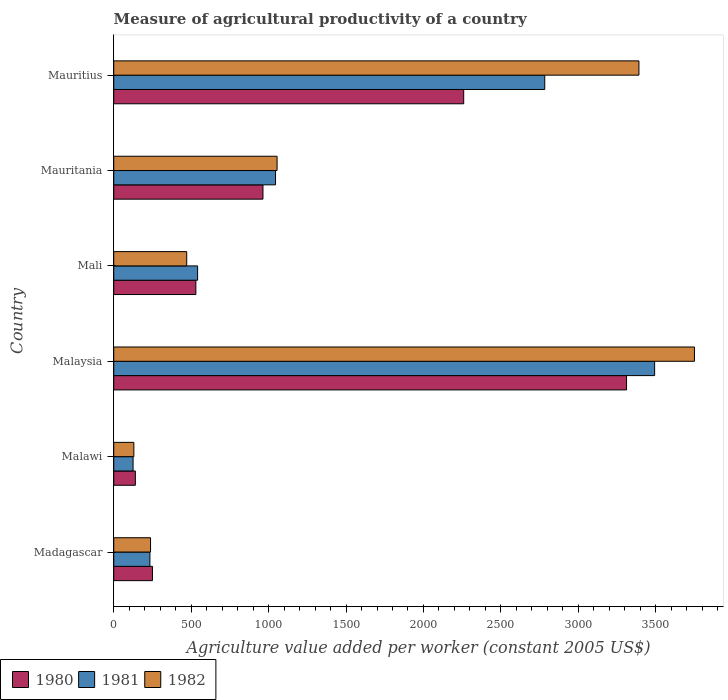Are the number of bars per tick equal to the number of legend labels?
Your answer should be compact. Yes. How many bars are there on the 6th tick from the top?
Make the answer very short. 3. How many bars are there on the 2nd tick from the bottom?
Your answer should be compact. 3. What is the label of the 6th group of bars from the top?
Give a very brief answer. Madagascar. In how many cases, is the number of bars for a given country not equal to the number of legend labels?
Ensure brevity in your answer.  0. What is the measure of agricultural productivity in 1982 in Mauritania?
Make the answer very short. 1054.73. Across all countries, what is the maximum measure of agricultural productivity in 1980?
Your answer should be compact. 3311.27. Across all countries, what is the minimum measure of agricultural productivity in 1980?
Provide a succinct answer. 139.62. In which country was the measure of agricultural productivity in 1980 maximum?
Your answer should be compact. Malaysia. In which country was the measure of agricultural productivity in 1980 minimum?
Offer a very short reply. Malawi. What is the total measure of agricultural productivity in 1982 in the graph?
Provide a succinct answer. 9034.51. What is the difference between the measure of agricultural productivity in 1981 in Mali and that in Mauritius?
Ensure brevity in your answer.  -2241.48. What is the difference between the measure of agricultural productivity in 1982 in Mauritius and the measure of agricultural productivity in 1980 in Madagascar?
Offer a very short reply. 3141.07. What is the average measure of agricultural productivity in 1982 per country?
Your answer should be very brief. 1505.75. What is the difference between the measure of agricultural productivity in 1980 and measure of agricultural productivity in 1981 in Mali?
Your response must be concise. -11.31. In how many countries, is the measure of agricultural productivity in 1981 greater than 1400 US$?
Give a very brief answer. 2. What is the ratio of the measure of agricultural productivity in 1980 in Malawi to that in Mauritania?
Provide a succinct answer. 0.14. What is the difference between the highest and the second highest measure of agricultural productivity in 1981?
Give a very brief answer. 709.52. What is the difference between the highest and the lowest measure of agricultural productivity in 1982?
Your response must be concise. 3619.9. In how many countries, is the measure of agricultural productivity in 1981 greater than the average measure of agricultural productivity in 1981 taken over all countries?
Your answer should be compact. 2. Is it the case that in every country, the sum of the measure of agricultural productivity in 1981 and measure of agricultural productivity in 1980 is greater than the measure of agricultural productivity in 1982?
Keep it short and to the point. Yes. How many countries are there in the graph?
Offer a very short reply. 6. What is the difference between two consecutive major ticks on the X-axis?
Offer a very short reply. 500. Does the graph contain any zero values?
Your answer should be compact. No. How many legend labels are there?
Offer a terse response. 3. What is the title of the graph?
Your answer should be compact. Measure of agricultural productivity of a country. What is the label or title of the X-axis?
Ensure brevity in your answer.  Agriculture value added per worker (constant 2005 US$). What is the label or title of the Y-axis?
Your answer should be compact. Country. What is the Agriculture value added per worker (constant 2005 US$) of 1980 in Madagascar?
Offer a very short reply. 250.1. What is the Agriculture value added per worker (constant 2005 US$) in 1981 in Madagascar?
Provide a succinct answer. 233.51. What is the Agriculture value added per worker (constant 2005 US$) in 1982 in Madagascar?
Offer a terse response. 237.65. What is the Agriculture value added per worker (constant 2005 US$) in 1980 in Malawi?
Give a very brief answer. 139.62. What is the Agriculture value added per worker (constant 2005 US$) of 1981 in Malawi?
Make the answer very short. 124.86. What is the Agriculture value added per worker (constant 2005 US$) of 1982 in Malawi?
Your response must be concise. 129.9. What is the Agriculture value added per worker (constant 2005 US$) in 1980 in Malaysia?
Keep it short and to the point. 3311.27. What is the Agriculture value added per worker (constant 2005 US$) in 1981 in Malaysia?
Your answer should be compact. 3492.6. What is the Agriculture value added per worker (constant 2005 US$) of 1982 in Malaysia?
Your answer should be very brief. 3749.8. What is the Agriculture value added per worker (constant 2005 US$) in 1980 in Mali?
Provide a short and direct response. 530.29. What is the Agriculture value added per worker (constant 2005 US$) of 1981 in Mali?
Provide a short and direct response. 541.6. What is the Agriculture value added per worker (constant 2005 US$) of 1982 in Mali?
Your response must be concise. 471.28. What is the Agriculture value added per worker (constant 2005 US$) of 1980 in Mauritania?
Provide a short and direct response. 963.64. What is the Agriculture value added per worker (constant 2005 US$) of 1981 in Mauritania?
Offer a terse response. 1044.71. What is the Agriculture value added per worker (constant 2005 US$) of 1982 in Mauritania?
Make the answer very short. 1054.73. What is the Agriculture value added per worker (constant 2005 US$) of 1980 in Mauritius?
Make the answer very short. 2259.73. What is the Agriculture value added per worker (constant 2005 US$) of 1981 in Mauritius?
Make the answer very short. 2783.08. What is the Agriculture value added per worker (constant 2005 US$) of 1982 in Mauritius?
Make the answer very short. 3391.17. Across all countries, what is the maximum Agriculture value added per worker (constant 2005 US$) in 1980?
Your answer should be very brief. 3311.27. Across all countries, what is the maximum Agriculture value added per worker (constant 2005 US$) in 1981?
Your response must be concise. 3492.6. Across all countries, what is the maximum Agriculture value added per worker (constant 2005 US$) in 1982?
Your answer should be very brief. 3749.8. Across all countries, what is the minimum Agriculture value added per worker (constant 2005 US$) of 1980?
Give a very brief answer. 139.62. Across all countries, what is the minimum Agriculture value added per worker (constant 2005 US$) of 1981?
Make the answer very short. 124.86. Across all countries, what is the minimum Agriculture value added per worker (constant 2005 US$) of 1982?
Make the answer very short. 129.9. What is the total Agriculture value added per worker (constant 2005 US$) in 1980 in the graph?
Your answer should be compact. 7454.65. What is the total Agriculture value added per worker (constant 2005 US$) in 1981 in the graph?
Provide a short and direct response. 8220.37. What is the total Agriculture value added per worker (constant 2005 US$) of 1982 in the graph?
Give a very brief answer. 9034.51. What is the difference between the Agriculture value added per worker (constant 2005 US$) in 1980 in Madagascar and that in Malawi?
Your response must be concise. 110.47. What is the difference between the Agriculture value added per worker (constant 2005 US$) in 1981 in Madagascar and that in Malawi?
Provide a short and direct response. 108.65. What is the difference between the Agriculture value added per worker (constant 2005 US$) in 1982 in Madagascar and that in Malawi?
Your answer should be compact. 107.75. What is the difference between the Agriculture value added per worker (constant 2005 US$) of 1980 in Madagascar and that in Malaysia?
Your response must be concise. -3061.17. What is the difference between the Agriculture value added per worker (constant 2005 US$) of 1981 in Madagascar and that in Malaysia?
Ensure brevity in your answer.  -3259.09. What is the difference between the Agriculture value added per worker (constant 2005 US$) in 1982 in Madagascar and that in Malaysia?
Your response must be concise. -3512.15. What is the difference between the Agriculture value added per worker (constant 2005 US$) in 1980 in Madagascar and that in Mali?
Ensure brevity in your answer.  -280.19. What is the difference between the Agriculture value added per worker (constant 2005 US$) of 1981 in Madagascar and that in Mali?
Provide a succinct answer. -308.09. What is the difference between the Agriculture value added per worker (constant 2005 US$) in 1982 in Madagascar and that in Mali?
Offer a very short reply. -233.63. What is the difference between the Agriculture value added per worker (constant 2005 US$) in 1980 in Madagascar and that in Mauritania?
Give a very brief answer. -713.54. What is the difference between the Agriculture value added per worker (constant 2005 US$) in 1981 in Madagascar and that in Mauritania?
Your answer should be very brief. -811.19. What is the difference between the Agriculture value added per worker (constant 2005 US$) of 1982 in Madagascar and that in Mauritania?
Keep it short and to the point. -817.08. What is the difference between the Agriculture value added per worker (constant 2005 US$) of 1980 in Madagascar and that in Mauritius?
Offer a very short reply. -2009.63. What is the difference between the Agriculture value added per worker (constant 2005 US$) of 1981 in Madagascar and that in Mauritius?
Give a very brief answer. -2549.57. What is the difference between the Agriculture value added per worker (constant 2005 US$) of 1982 in Madagascar and that in Mauritius?
Make the answer very short. -3153.52. What is the difference between the Agriculture value added per worker (constant 2005 US$) in 1980 in Malawi and that in Malaysia?
Give a very brief answer. -3171.65. What is the difference between the Agriculture value added per worker (constant 2005 US$) in 1981 in Malawi and that in Malaysia?
Give a very brief answer. -3367.74. What is the difference between the Agriculture value added per worker (constant 2005 US$) in 1982 in Malawi and that in Malaysia?
Provide a short and direct response. -3619.9. What is the difference between the Agriculture value added per worker (constant 2005 US$) in 1980 in Malawi and that in Mali?
Your answer should be compact. -390.66. What is the difference between the Agriculture value added per worker (constant 2005 US$) of 1981 in Malawi and that in Mali?
Your response must be concise. -416.74. What is the difference between the Agriculture value added per worker (constant 2005 US$) of 1982 in Malawi and that in Mali?
Provide a succinct answer. -341.38. What is the difference between the Agriculture value added per worker (constant 2005 US$) of 1980 in Malawi and that in Mauritania?
Ensure brevity in your answer.  -824.02. What is the difference between the Agriculture value added per worker (constant 2005 US$) in 1981 in Malawi and that in Mauritania?
Your response must be concise. -919.84. What is the difference between the Agriculture value added per worker (constant 2005 US$) of 1982 in Malawi and that in Mauritania?
Your response must be concise. -924.83. What is the difference between the Agriculture value added per worker (constant 2005 US$) in 1980 in Malawi and that in Mauritius?
Provide a short and direct response. -2120.1. What is the difference between the Agriculture value added per worker (constant 2005 US$) in 1981 in Malawi and that in Mauritius?
Offer a very short reply. -2658.22. What is the difference between the Agriculture value added per worker (constant 2005 US$) in 1982 in Malawi and that in Mauritius?
Your answer should be compact. -3261.27. What is the difference between the Agriculture value added per worker (constant 2005 US$) in 1980 in Malaysia and that in Mali?
Give a very brief answer. 2780.98. What is the difference between the Agriculture value added per worker (constant 2005 US$) in 1981 in Malaysia and that in Mali?
Offer a terse response. 2951. What is the difference between the Agriculture value added per worker (constant 2005 US$) in 1982 in Malaysia and that in Mali?
Your response must be concise. 3278.52. What is the difference between the Agriculture value added per worker (constant 2005 US$) of 1980 in Malaysia and that in Mauritania?
Offer a very short reply. 2347.63. What is the difference between the Agriculture value added per worker (constant 2005 US$) in 1981 in Malaysia and that in Mauritania?
Make the answer very short. 2447.9. What is the difference between the Agriculture value added per worker (constant 2005 US$) of 1982 in Malaysia and that in Mauritania?
Give a very brief answer. 2695.07. What is the difference between the Agriculture value added per worker (constant 2005 US$) of 1980 in Malaysia and that in Mauritius?
Your response must be concise. 1051.54. What is the difference between the Agriculture value added per worker (constant 2005 US$) of 1981 in Malaysia and that in Mauritius?
Your answer should be compact. 709.52. What is the difference between the Agriculture value added per worker (constant 2005 US$) of 1982 in Malaysia and that in Mauritius?
Your response must be concise. 358.63. What is the difference between the Agriculture value added per worker (constant 2005 US$) in 1980 in Mali and that in Mauritania?
Your response must be concise. -433.35. What is the difference between the Agriculture value added per worker (constant 2005 US$) in 1981 in Mali and that in Mauritania?
Provide a short and direct response. -503.1. What is the difference between the Agriculture value added per worker (constant 2005 US$) in 1982 in Mali and that in Mauritania?
Offer a very short reply. -583.45. What is the difference between the Agriculture value added per worker (constant 2005 US$) in 1980 in Mali and that in Mauritius?
Provide a succinct answer. -1729.44. What is the difference between the Agriculture value added per worker (constant 2005 US$) of 1981 in Mali and that in Mauritius?
Your answer should be very brief. -2241.48. What is the difference between the Agriculture value added per worker (constant 2005 US$) in 1982 in Mali and that in Mauritius?
Give a very brief answer. -2919.89. What is the difference between the Agriculture value added per worker (constant 2005 US$) in 1980 in Mauritania and that in Mauritius?
Make the answer very short. -1296.09. What is the difference between the Agriculture value added per worker (constant 2005 US$) of 1981 in Mauritania and that in Mauritius?
Give a very brief answer. -1738.38. What is the difference between the Agriculture value added per worker (constant 2005 US$) of 1982 in Mauritania and that in Mauritius?
Offer a very short reply. -2336.44. What is the difference between the Agriculture value added per worker (constant 2005 US$) of 1980 in Madagascar and the Agriculture value added per worker (constant 2005 US$) of 1981 in Malawi?
Make the answer very short. 125.24. What is the difference between the Agriculture value added per worker (constant 2005 US$) of 1980 in Madagascar and the Agriculture value added per worker (constant 2005 US$) of 1982 in Malawi?
Your answer should be very brief. 120.2. What is the difference between the Agriculture value added per worker (constant 2005 US$) of 1981 in Madagascar and the Agriculture value added per worker (constant 2005 US$) of 1982 in Malawi?
Provide a succinct answer. 103.61. What is the difference between the Agriculture value added per worker (constant 2005 US$) in 1980 in Madagascar and the Agriculture value added per worker (constant 2005 US$) in 1981 in Malaysia?
Your answer should be very brief. -3242.5. What is the difference between the Agriculture value added per worker (constant 2005 US$) of 1980 in Madagascar and the Agriculture value added per worker (constant 2005 US$) of 1982 in Malaysia?
Provide a short and direct response. -3499.7. What is the difference between the Agriculture value added per worker (constant 2005 US$) of 1981 in Madagascar and the Agriculture value added per worker (constant 2005 US$) of 1982 in Malaysia?
Give a very brief answer. -3516.29. What is the difference between the Agriculture value added per worker (constant 2005 US$) of 1980 in Madagascar and the Agriculture value added per worker (constant 2005 US$) of 1981 in Mali?
Give a very brief answer. -291.5. What is the difference between the Agriculture value added per worker (constant 2005 US$) in 1980 in Madagascar and the Agriculture value added per worker (constant 2005 US$) in 1982 in Mali?
Offer a terse response. -221.18. What is the difference between the Agriculture value added per worker (constant 2005 US$) in 1981 in Madagascar and the Agriculture value added per worker (constant 2005 US$) in 1982 in Mali?
Make the answer very short. -237.76. What is the difference between the Agriculture value added per worker (constant 2005 US$) of 1980 in Madagascar and the Agriculture value added per worker (constant 2005 US$) of 1981 in Mauritania?
Offer a very short reply. -794.61. What is the difference between the Agriculture value added per worker (constant 2005 US$) in 1980 in Madagascar and the Agriculture value added per worker (constant 2005 US$) in 1982 in Mauritania?
Provide a succinct answer. -804.63. What is the difference between the Agriculture value added per worker (constant 2005 US$) in 1981 in Madagascar and the Agriculture value added per worker (constant 2005 US$) in 1982 in Mauritania?
Provide a succinct answer. -821.21. What is the difference between the Agriculture value added per worker (constant 2005 US$) of 1980 in Madagascar and the Agriculture value added per worker (constant 2005 US$) of 1981 in Mauritius?
Your response must be concise. -2532.98. What is the difference between the Agriculture value added per worker (constant 2005 US$) of 1980 in Madagascar and the Agriculture value added per worker (constant 2005 US$) of 1982 in Mauritius?
Offer a terse response. -3141.07. What is the difference between the Agriculture value added per worker (constant 2005 US$) in 1981 in Madagascar and the Agriculture value added per worker (constant 2005 US$) in 1982 in Mauritius?
Provide a succinct answer. -3157.66. What is the difference between the Agriculture value added per worker (constant 2005 US$) in 1980 in Malawi and the Agriculture value added per worker (constant 2005 US$) in 1981 in Malaysia?
Ensure brevity in your answer.  -3352.98. What is the difference between the Agriculture value added per worker (constant 2005 US$) in 1980 in Malawi and the Agriculture value added per worker (constant 2005 US$) in 1982 in Malaysia?
Keep it short and to the point. -3610.18. What is the difference between the Agriculture value added per worker (constant 2005 US$) in 1981 in Malawi and the Agriculture value added per worker (constant 2005 US$) in 1982 in Malaysia?
Your answer should be very brief. -3624.94. What is the difference between the Agriculture value added per worker (constant 2005 US$) of 1980 in Malawi and the Agriculture value added per worker (constant 2005 US$) of 1981 in Mali?
Give a very brief answer. -401.98. What is the difference between the Agriculture value added per worker (constant 2005 US$) of 1980 in Malawi and the Agriculture value added per worker (constant 2005 US$) of 1982 in Mali?
Your answer should be compact. -331.65. What is the difference between the Agriculture value added per worker (constant 2005 US$) of 1981 in Malawi and the Agriculture value added per worker (constant 2005 US$) of 1982 in Mali?
Offer a terse response. -346.41. What is the difference between the Agriculture value added per worker (constant 2005 US$) of 1980 in Malawi and the Agriculture value added per worker (constant 2005 US$) of 1981 in Mauritania?
Your answer should be compact. -905.08. What is the difference between the Agriculture value added per worker (constant 2005 US$) of 1980 in Malawi and the Agriculture value added per worker (constant 2005 US$) of 1982 in Mauritania?
Ensure brevity in your answer.  -915.1. What is the difference between the Agriculture value added per worker (constant 2005 US$) in 1981 in Malawi and the Agriculture value added per worker (constant 2005 US$) in 1982 in Mauritania?
Provide a succinct answer. -929.86. What is the difference between the Agriculture value added per worker (constant 2005 US$) of 1980 in Malawi and the Agriculture value added per worker (constant 2005 US$) of 1981 in Mauritius?
Your response must be concise. -2643.46. What is the difference between the Agriculture value added per worker (constant 2005 US$) in 1980 in Malawi and the Agriculture value added per worker (constant 2005 US$) in 1982 in Mauritius?
Provide a succinct answer. -3251.54. What is the difference between the Agriculture value added per worker (constant 2005 US$) in 1981 in Malawi and the Agriculture value added per worker (constant 2005 US$) in 1982 in Mauritius?
Make the answer very short. -3266.3. What is the difference between the Agriculture value added per worker (constant 2005 US$) of 1980 in Malaysia and the Agriculture value added per worker (constant 2005 US$) of 1981 in Mali?
Make the answer very short. 2769.67. What is the difference between the Agriculture value added per worker (constant 2005 US$) in 1980 in Malaysia and the Agriculture value added per worker (constant 2005 US$) in 1982 in Mali?
Offer a terse response. 2839.99. What is the difference between the Agriculture value added per worker (constant 2005 US$) of 1981 in Malaysia and the Agriculture value added per worker (constant 2005 US$) of 1982 in Mali?
Give a very brief answer. 3021.32. What is the difference between the Agriculture value added per worker (constant 2005 US$) of 1980 in Malaysia and the Agriculture value added per worker (constant 2005 US$) of 1981 in Mauritania?
Provide a succinct answer. 2266.57. What is the difference between the Agriculture value added per worker (constant 2005 US$) in 1980 in Malaysia and the Agriculture value added per worker (constant 2005 US$) in 1982 in Mauritania?
Ensure brevity in your answer.  2256.54. What is the difference between the Agriculture value added per worker (constant 2005 US$) of 1981 in Malaysia and the Agriculture value added per worker (constant 2005 US$) of 1982 in Mauritania?
Provide a short and direct response. 2437.88. What is the difference between the Agriculture value added per worker (constant 2005 US$) of 1980 in Malaysia and the Agriculture value added per worker (constant 2005 US$) of 1981 in Mauritius?
Your response must be concise. 528.19. What is the difference between the Agriculture value added per worker (constant 2005 US$) in 1980 in Malaysia and the Agriculture value added per worker (constant 2005 US$) in 1982 in Mauritius?
Offer a terse response. -79.9. What is the difference between the Agriculture value added per worker (constant 2005 US$) in 1981 in Malaysia and the Agriculture value added per worker (constant 2005 US$) in 1982 in Mauritius?
Your response must be concise. 101.43. What is the difference between the Agriculture value added per worker (constant 2005 US$) in 1980 in Mali and the Agriculture value added per worker (constant 2005 US$) in 1981 in Mauritania?
Keep it short and to the point. -514.42. What is the difference between the Agriculture value added per worker (constant 2005 US$) in 1980 in Mali and the Agriculture value added per worker (constant 2005 US$) in 1982 in Mauritania?
Provide a short and direct response. -524.44. What is the difference between the Agriculture value added per worker (constant 2005 US$) in 1981 in Mali and the Agriculture value added per worker (constant 2005 US$) in 1982 in Mauritania?
Your answer should be compact. -513.12. What is the difference between the Agriculture value added per worker (constant 2005 US$) in 1980 in Mali and the Agriculture value added per worker (constant 2005 US$) in 1981 in Mauritius?
Ensure brevity in your answer.  -2252.79. What is the difference between the Agriculture value added per worker (constant 2005 US$) in 1980 in Mali and the Agriculture value added per worker (constant 2005 US$) in 1982 in Mauritius?
Give a very brief answer. -2860.88. What is the difference between the Agriculture value added per worker (constant 2005 US$) of 1981 in Mali and the Agriculture value added per worker (constant 2005 US$) of 1982 in Mauritius?
Offer a terse response. -2849.57. What is the difference between the Agriculture value added per worker (constant 2005 US$) in 1980 in Mauritania and the Agriculture value added per worker (constant 2005 US$) in 1981 in Mauritius?
Your answer should be compact. -1819.44. What is the difference between the Agriculture value added per worker (constant 2005 US$) in 1980 in Mauritania and the Agriculture value added per worker (constant 2005 US$) in 1982 in Mauritius?
Your answer should be compact. -2427.53. What is the difference between the Agriculture value added per worker (constant 2005 US$) in 1981 in Mauritania and the Agriculture value added per worker (constant 2005 US$) in 1982 in Mauritius?
Your answer should be very brief. -2346.46. What is the average Agriculture value added per worker (constant 2005 US$) of 1980 per country?
Your answer should be compact. 1242.44. What is the average Agriculture value added per worker (constant 2005 US$) of 1981 per country?
Provide a short and direct response. 1370.06. What is the average Agriculture value added per worker (constant 2005 US$) in 1982 per country?
Offer a terse response. 1505.75. What is the difference between the Agriculture value added per worker (constant 2005 US$) of 1980 and Agriculture value added per worker (constant 2005 US$) of 1981 in Madagascar?
Your answer should be very brief. 16.59. What is the difference between the Agriculture value added per worker (constant 2005 US$) in 1980 and Agriculture value added per worker (constant 2005 US$) in 1982 in Madagascar?
Provide a short and direct response. 12.45. What is the difference between the Agriculture value added per worker (constant 2005 US$) in 1981 and Agriculture value added per worker (constant 2005 US$) in 1982 in Madagascar?
Ensure brevity in your answer.  -4.13. What is the difference between the Agriculture value added per worker (constant 2005 US$) of 1980 and Agriculture value added per worker (constant 2005 US$) of 1981 in Malawi?
Provide a succinct answer. 14.76. What is the difference between the Agriculture value added per worker (constant 2005 US$) in 1980 and Agriculture value added per worker (constant 2005 US$) in 1982 in Malawi?
Your answer should be very brief. 9.73. What is the difference between the Agriculture value added per worker (constant 2005 US$) in 1981 and Agriculture value added per worker (constant 2005 US$) in 1982 in Malawi?
Make the answer very short. -5.03. What is the difference between the Agriculture value added per worker (constant 2005 US$) of 1980 and Agriculture value added per worker (constant 2005 US$) of 1981 in Malaysia?
Keep it short and to the point. -181.33. What is the difference between the Agriculture value added per worker (constant 2005 US$) in 1980 and Agriculture value added per worker (constant 2005 US$) in 1982 in Malaysia?
Provide a short and direct response. -438.53. What is the difference between the Agriculture value added per worker (constant 2005 US$) in 1981 and Agriculture value added per worker (constant 2005 US$) in 1982 in Malaysia?
Offer a very short reply. -257.2. What is the difference between the Agriculture value added per worker (constant 2005 US$) of 1980 and Agriculture value added per worker (constant 2005 US$) of 1981 in Mali?
Keep it short and to the point. -11.31. What is the difference between the Agriculture value added per worker (constant 2005 US$) in 1980 and Agriculture value added per worker (constant 2005 US$) in 1982 in Mali?
Offer a very short reply. 59.01. What is the difference between the Agriculture value added per worker (constant 2005 US$) in 1981 and Agriculture value added per worker (constant 2005 US$) in 1982 in Mali?
Give a very brief answer. 70.33. What is the difference between the Agriculture value added per worker (constant 2005 US$) of 1980 and Agriculture value added per worker (constant 2005 US$) of 1981 in Mauritania?
Ensure brevity in your answer.  -81.06. What is the difference between the Agriculture value added per worker (constant 2005 US$) in 1980 and Agriculture value added per worker (constant 2005 US$) in 1982 in Mauritania?
Provide a succinct answer. -91.08. What is the difference between the Agriculture value added per worker (constant 2005 US$) in 1981 and Agriculture value added per worker (constant 2005 US$) in 1982 in Mauritania?
Make the answer very short. -10.02. What is the difference between the Agriculture value added per worker (constant 2005 US$) of 1980 and Agriculture value added per worker (constant 2005 US$) of 1981 in Mauritius?
Provide a succinct answer. -523.35. What is the difference between the Agriculture value added per worker (constant 2005 US$) of 1980 and Agriculture value added per worker (constant 2005 US$) of 1982 in Mauritius?
Provide a short and direct response. -1131.44. What is the difference between the Agriculture value added per worker (constant 2005 US$) in 1981 and Agriculture value added per worker (constant 2005 US$) in 1982 in Mauritius?
Provide a short and direct response. -608.09. What is the ratio of the Agriculture value added per worker (constant 2005 US$) in 1980 in Madagascar to that in Malawi?
Offer a terse response. 1.79. What is the ratio of the Agriculture value added per worker (constant 2005 US$) of 1981 in Madagascar to that in Malawi?
Make the answer very short. 1.87. What is the ratio of the Agriculture value added per worker (constant 2005 US$) in 1982 in Madagascar to that in Malawi?
Make the answer very short. 1.83. What is the ratio of the Agriculture value added per worker (constant 2005 US$) of 1980 in Madagascar to that in Malaysia?
Provide a succinct answer. 0.08. What is the ratio of the Agriculture value added per worker (constant 2005 US$) of 1981 in Madagascar to that in Malaysia?
Provide a succinct answer. 0.07. What is the ratio of the Agriculture value added per worker (constant 2005 US$) in 1982 in Madagascar to that in Malaysia?
Provide a short and direct response. 0.06. What is the ratio of the Agriculture value added per worker (constant 2005 US$) of 1980 in Madagascar to that in Mali?
Provide a short and direct response. 0.47. What is the ratio of the Agriculture value added per worker (constant 2005 US$) in 1981 in Madagascar to that in Mali?
Provide a short and direct response. 0.43. What is the ratio of the Agriculture value added per worker (constant 2005 US$) in 1982 in Madagascar to that in Mali?
Provide a short and direct response. 0.5. What is the ratio of the Agriculture value added per worker (constant 2005 US$) in 1980 in Madagascar to that in Mauritania?
Keep it short and to the point. 0.26. What is the ratio of the Agriculture value added per worker (constant 2005 US$) of 1981 in Madagascar to that in Mauritania?
Provide a succinct answer. 0.22. What is the ratio of the Agriculture value added per worker (constant 2005 US$) of 1982 in Madagascar to that in Mauritania?
Give a very brief answer. 0.23. What is the ratio of the Agriculture value added per worker (constant 2005 US$) of 1980 in Madagascar to that in Mauritius?
Make the answer very short. 0.11. What is the ratio of the Agriculture value added per worker (constant 2005 US$) in 1981 in Madagascar to that in Mauritius?
Offer a terse response. 0.08. What is the ratio of the Agriculture value added per worker (constant 2005 US$) in 1982 in Madagascar to that in Mauritius?
Your answer should be very brief. 0.07. What is the ratio of the Agriculture value added per worker (constant 2005 US$) of 1980 in Malawi to that in Malaysia?
Offer a terse response. 0.04. What is the ratio of the Agriculture value added per worker (constant 2005 US$) in 1981 in Malawi to that in Malaysia?
Offer a terse response. 0.04. What is the ratio of the Agriculture value added per worker (constant 2005 US$) of 1982 in Malawi to that in Malaysia?
Keep it short and to the point. 0.03. What is the ratio of the Agriculture value added per worker (constant 2005 US$) in 1980 in Malawi to that in Mali?
Provide a short and direct response. 0.26. What is the ratio of the Agriculture value added per worker (constant 2005 US$) of 1981 in Malawi to that in Mali?
Your answer should be very brief. 0.23. What is the ratio of the Agriculture value added per worker (constant 2005 US$) in 1982 in Malawi to that in Mali?
Provide a short and direct response. 0.28. What is the ratio of the Agriculture value added per worker (constant 2005 US$) of 1980 in Malawi to that in Mauritania?
Your response must be concise. 0.14. What is the ratio of the Agriculture value added per worker (constant 2005 US$) of 1981 in Malawi to that in Mauritania?
Ensure brevity in your answer.  0.12. What is the ratio of the Agriculture value added per worker (constant 2005 US$) of 1982 in Malawi to that in Mauritania?
Ensure brevity in your answer.  0.12. What is the ratio of the Agriculture value added per worker (constant 2005 US$) of 1980 in Malawi to that in Mauritius?
Offer a terse response. 0.06. What is the ratio of the Agriculture value added per worker (constant 2005 US$) in 1981 in Malawi to that in Mauritius?
Keep it short and to the point. 0.04. What is the ratio of the Agriculture value added per worker (constant 2005 US$) in 1982 in Malawi to that in Mauritius?
Offer a very short reply. 0.04. What is the ratio of the Agriculture value added per worker (constant 2005 US$) in 1980 in Malaysia to that in Mali?
Offer a very short reply. 6.24. What is the ratio of the Agriculture value added per worker (constant 2005 US$) in 1981 in Malaysia to that in Mali?
Ensure brevity in your answer.  6.45. What is the ratio of the Agriculture value added per worker (constant 2005 US$) of 1982 in Malaysia to that in Mali?
Ensure brevity in your answer.  7.96. What is the ratio of the Agriculture value added per worker (constant 2005 US$) of 1980 in Malaysia to that in Mauritania?
Give a very brief answer. 3.44. What is the ratio of the Agriculture value added per worker (constant 2005 US$) of 1981 in Malaysia to that in Mauritania?
Provide a short and direct response. 3.34. What is the ratio of the Agriculture value added per worker (constant 2005 US$) of 1982 in Malaysia to that in Mauritania?
Give a very brief answer. 3.56. What is the ratio of the Agriculture value added per worker (constant 2005 US$) in 1980 in Malaysia to that in Mauritius?
Your response must be concise. 1.47. What is the ratio of the Agriculture value added per worker (constant 2005 US$) in 1981 in Malaysia to that in Mauritius?
Offer a terse response. 1.25. What is the ratio of the Agriculture value added per worker (constant 2005 US$) in 1982 in Malaysia to that in Mauritius?
Your answer should be compact. 1.11. What is the ratio of the Agriculture value added per worker (constant 2005 US$) of 1980 in Mali to that in Mauritania?
Provide a short and direct response. 0.55. What is the ratio of the Agriculture value added per worker (constant 2005 US$) in 1981 in Mali to that in Mauritania?
Provide a short and direct response. 0.52. What is the ratio of the Agriculture value added per worker (constant 2005 US$) of 1982 in Mali to that in Mauritania?
Your answer should be very brief. 0.45. What is the ratio of the Agriculture value added per worker (constant 2005 US$) in 1980 in Mali to that in Mauritius?
Offer a terse response. 0.23. What is the ratio of the Agriculture value added per worker (constant 2005 US$) in 1981 in Mali to that in Mauritius?
Keep it short and to the point. 0.19. What is the ratio of the Agriculture value added per worker (constant 2005 US$) of 1982 in Mali to that in Mauritius?
Your answer should be compact. 0.14. What is the ratio of the Agriculture value added per worker (constant 2005 US$) of 1980 in Mauritania to that in Mauritius?
Your answer should be very brief. 0.43. What is the ratio of the Agriculture value added per worker (constant 2005 US$) in 1981 in Mauritania to that in Mauritius?
Ensure brevity in your answer.  0.38. What is the ratio of the Agriculture value added per worker (constant 2005 US$) of 1982 in Mauritania to that in Mauritius?
Ensure brevity in your answer.  0.31. What is the difference between the highest and the second highest Agriculture value added per worker (constant 2005 US$) in 1980?
Your answer should be compact. 1051.54. What is the difference between the highest and the second highest Agriculture value added per worker (constant 2005 US$) in 1981?
Your answer should be compact. 709.52. What is the difference between the highest and the second highest Agriculture value added per worker (constant 2005 US$) of 1982?
Make the answer very short. 358.63. What is the difference between the highest and the lowest Agriculture value added per worker (constant 2005 US$) in 1980?
Keep it short and to the point. 3171.65. What is the difference between the highest and the lowest Agriculture value added per worker (constant 2005 US$) in 1981?
Keep it short and to the point. 3367.74. What is the difference between the highest and the lowest Agriculture value added per worker (constant 2005 US$) in 1982?
Provide a short and direct response. 3619.9. 